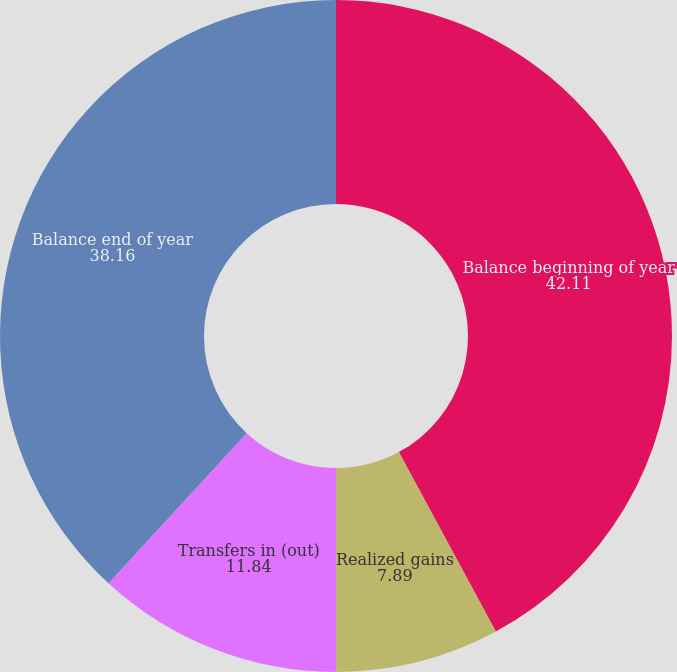<chart> <loc_0><loc_0><loc_500><loc_500><pie_chart><fcel>Balance beginning of year<fcel>Realized gains<fcel>Transfers in (out)<fcel>Balance end of year<nl><fcel>42.11%<fcel>7.89%<fcel>11.84%<fcel>38.16%<nl></chart> 